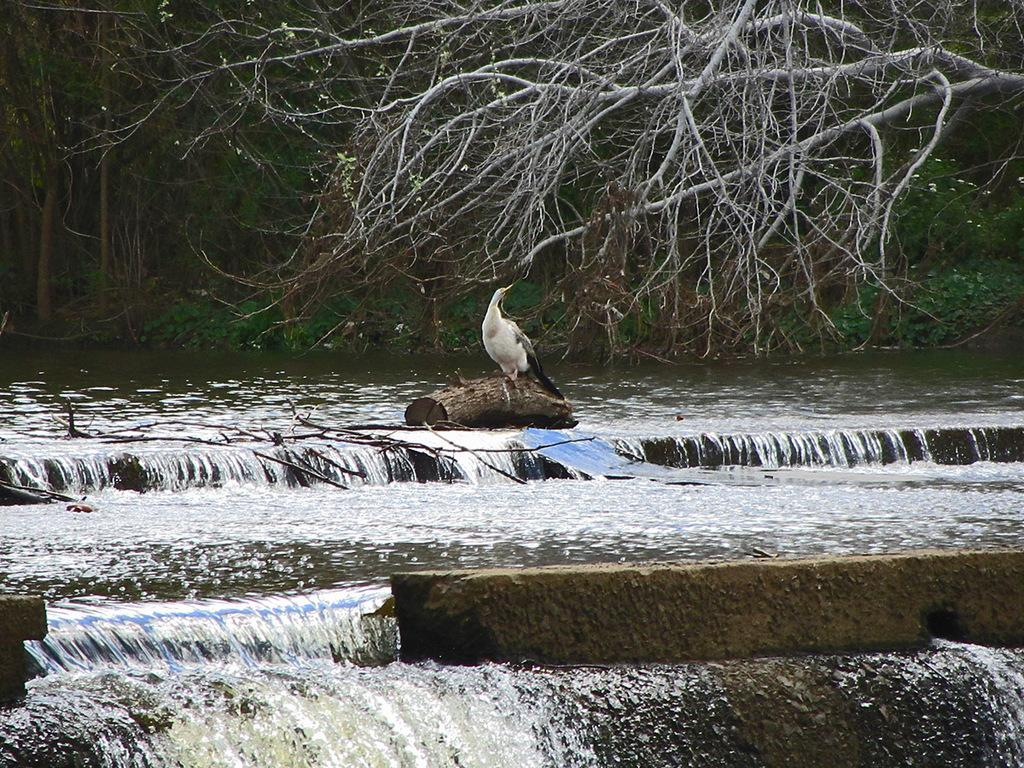What is the primary element visible in the image? There is water in the image. Can you describe the bird in the image? There is a bird sitting on a tree trunk in the image. What type of vegetation is present in the image? There are trees in the image. How much profit did the bird make from the lake in the image? There is no mention of a lake or profit in the image, and the bird is not engaged in any commercial activity. 